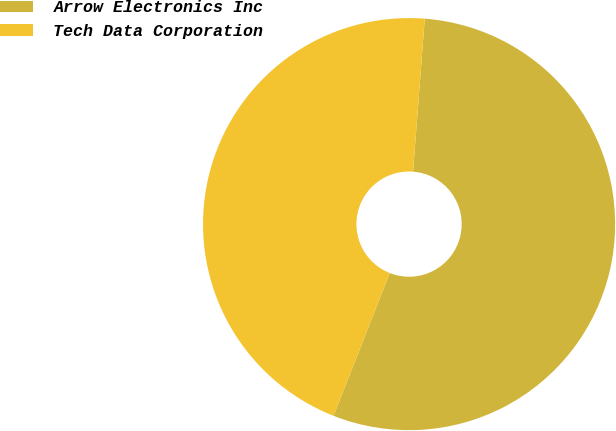Convert chart. <chart><loc_0><loc_0><loc_500><loc_500><pie_chart><fcel>Arrow Electronics Inc<fcel>Tech Data Corporation<nl><fcel>54.76%<fcel>45.24%<nl></chart> 